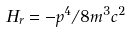Convert formula to latex. <formula><loc_0><loc_0><loc_500><loc_500>H _ { r } = - p ^ { 4 } / 8 m ^ { 3 } c ^ { 2 }</formula> 